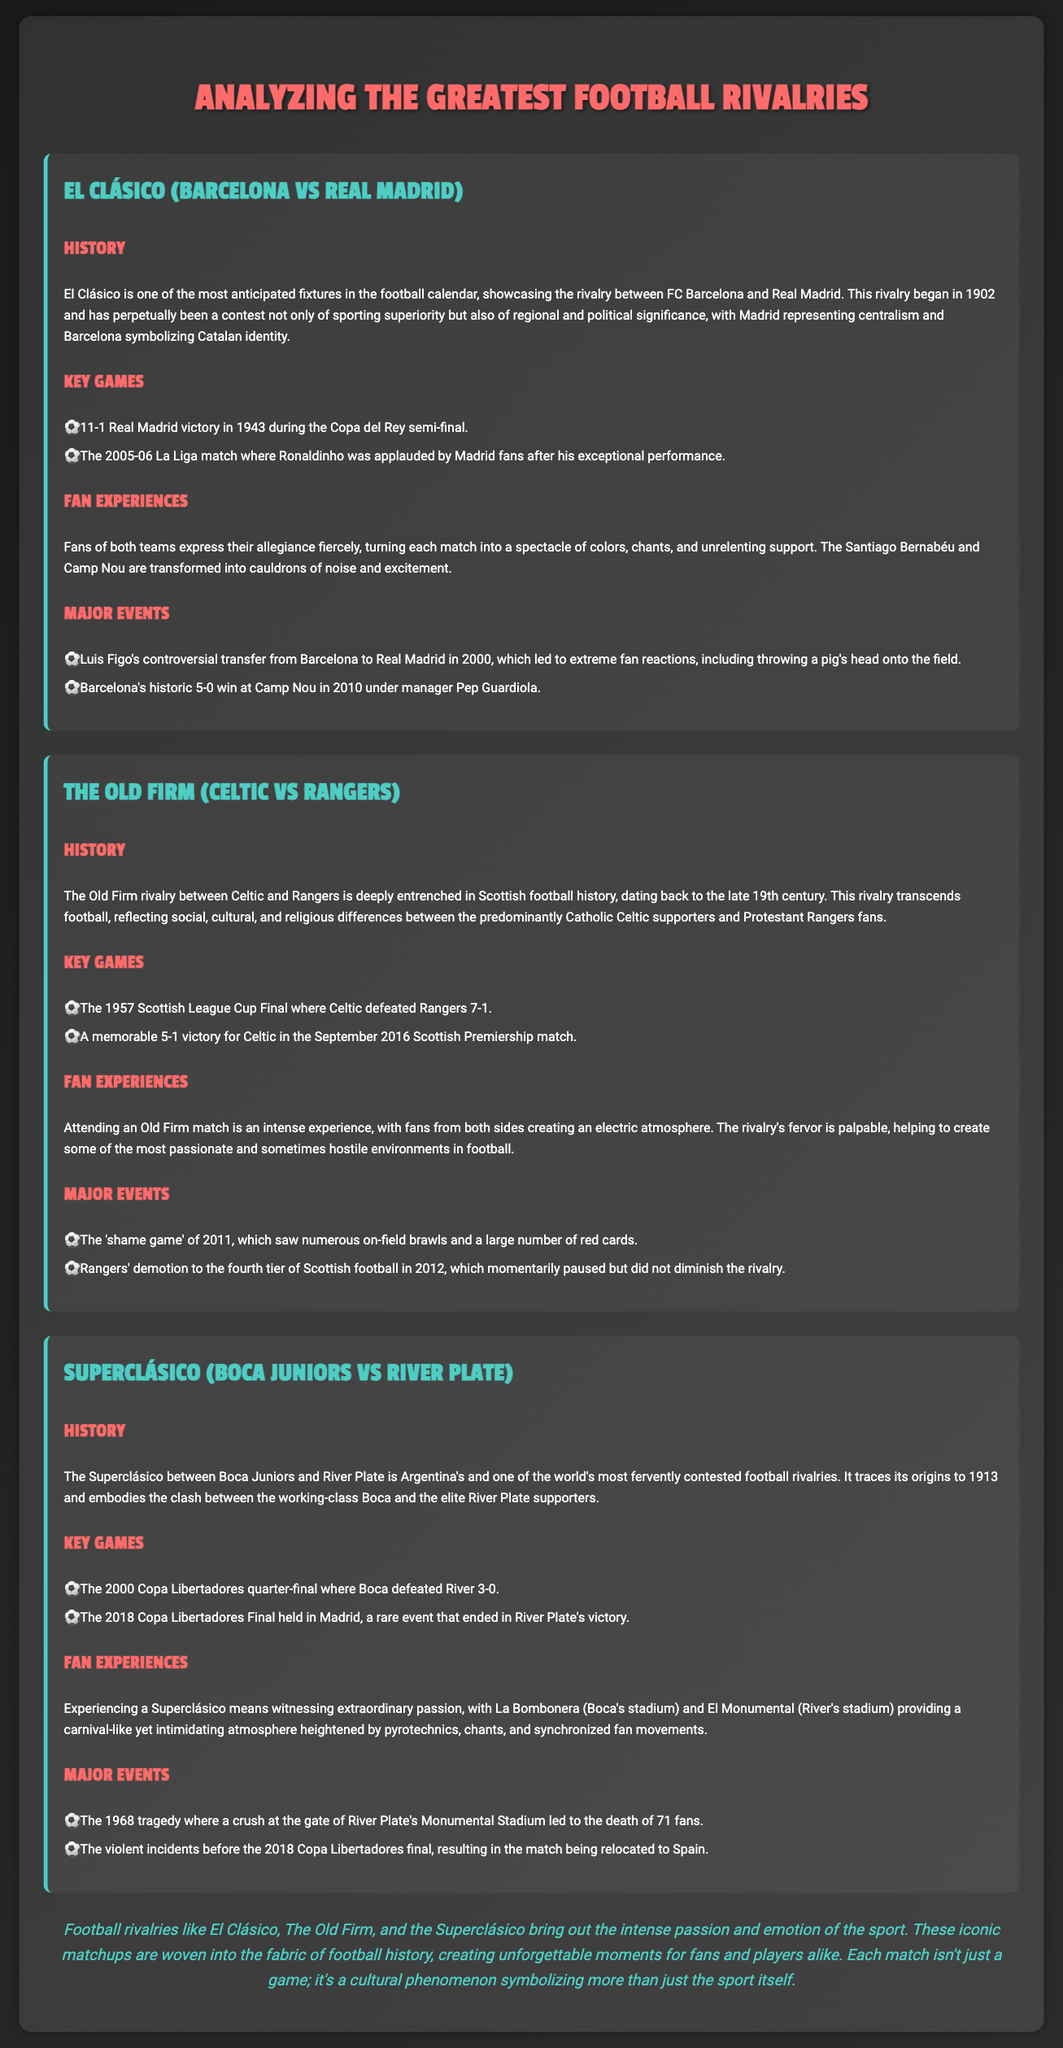what year did El Clásico begin? El Clásico began in 1902, as mentioned in the history section.
Answer: 1902 what was the score of the 1957 Scottish League Cup Final? Celtic defeated Rangers with a score of 7-1 in the 1957 Scottish League Cup Final.
Answer: 7-1 which stadium is known for Boca Juniors? La Bombonera is known for Boca Juniors, as stated in the fan experiences section.
Answer: La Bombonera what significant event occurred with Luis Figo in 2000? The significant event was Luis Figo's controversial transfer from Barcelona to Real Madrid in 2000.
Answer: Figo's transfer how many fans died in the 1968 tragedy? 71 fans died in the 1968 tragedy at River Plate's Monumental Stadium.
Answer: 71 which club won the 2018 Copa Libertadores Final? River Plate won the 2018 Copa Libertadores Final held in Madrid.
Answer: River Plate what major event happened in the Old Firm rivalry in 2011? The major event was the 'shame game' of 2011, involving on-field brawls and red cards.
Answer: 'Shame game' name a player who received applause from Madrid fans. Ronaldinho received applause from Madrid fans during the 2005-06 La Liga match.
Answer: Ronaldinho 